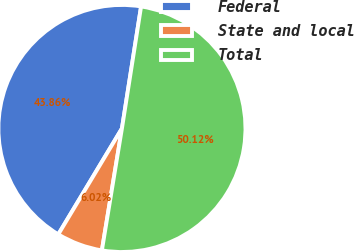<chart> <loc_0><loc_0><loc_500><loc_500><pie_chart><fcel>Federal<fcel>State and local<fcel>Total<nl><fcel>43.86%<fcel>6.02%<fcel>50.11%<nl></chart> 